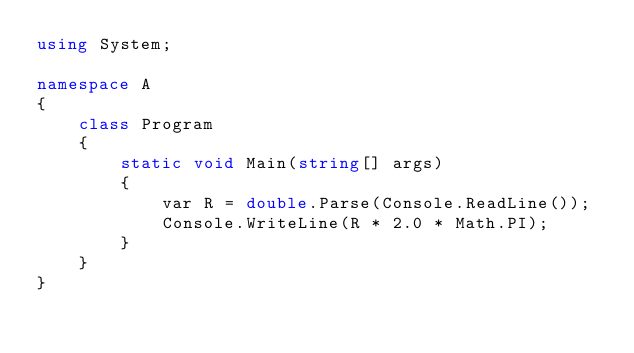Convert code to text. <code><loc_0><loc_0><loc_500><loc_500><_C#_>using System;

namespace A
{
    class Program
    {
        static void Main(string[] args)
        {
            var R = double.Parse(Console.ReadLine());
            Console.WriteLine(R * 2.0 * Math.PI);
        }
    }
}
</code> 